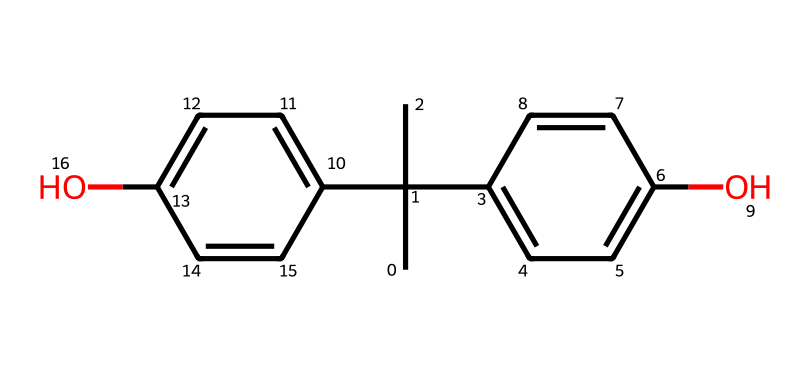What is the molecular formula of bisphenol A? To determine the molecular formula, we identify the elements present in the structure represented by the SMILES. Analyzing the structure, we find that it includes carbon (C), hydrogen (H), and oxygen (O) atoms. Counting the atoms, we find 15 carbon atoms, 16 hydrogen atoms, and 2 oxygen atoms, which gives us the formula C15H16O2.
Answer: C15H16O2 How many rings are present in the structure of bisphenol A? By examining the chemical structure in the SMILES notation, we can visually identify the rings. The presence of cyclic structures indicates how the carbon atoms are connected in a closed loop. In the structure of bisphenol A, there are two distinct phenolic rings, which represent two separate cycles.
Answer: 2 What type of linkage is found in bisphenol A? The structure depicts the covalent bonds between the carbon and oxygen atoms in bisphenol A. The connecting groups between the phenolic rings (the hydroxyl groups) indicate the existence of a diphenolic linkage. This type of linkage is characteristic of bisphenols and contributes to their chemical properties.
Answer: diphenolic Is bisphenol A considered a hazardous chemical? Bisphenol A has been extensively studied and is recognized for its potential endocrine-disrupting effects, which can pose health risks. Regulatory bodies have classified it as hazardous due to its association with negative health outcomes and environmental concerns.
Answer: yes How many hydrogen atoms are attached to the aromatic rings in bisphenol A? By analyzing the chemical structure, we observe that each aromatic ring typically has one hydrogen atom per carbon that is not connected to another substituent (like an OH group). There are a total of 8 aromatic carbons in the structure, leading to 8 hydrogen atoms attached to the rings after considering the substitutions.
Answer: 8 What functional groups are present in bisphenol A? Looking at the chemical structure, we identify the hydroxyl (-OH) groups attached to the aromatic rings. These functional groups are critical to the classification of bisphenol A as a phenol and influence its reactivity and biological activity.
Answer: hydroxyl groups 